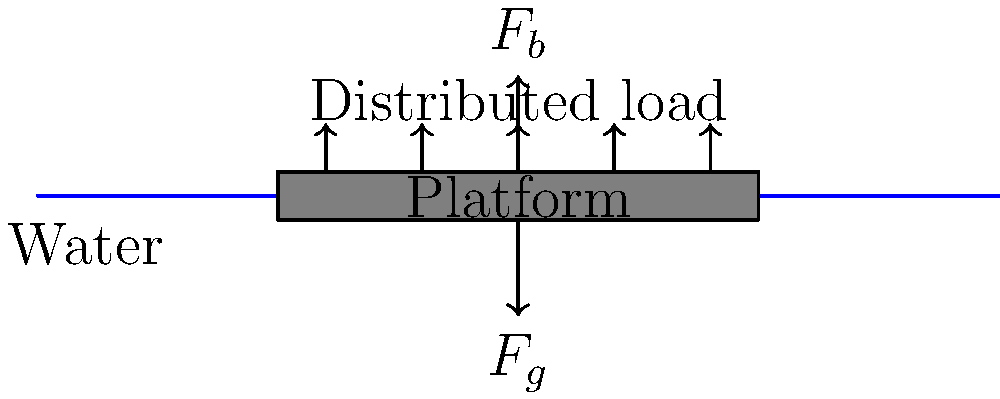A rectangular floating platform for algae cultivation measures 10 m x 5 m and has a uniform thickness of 0.5 m. The platform is made of a material with a density of 300 kg/m³. If the platform is designed to support a uniformly distributed load of algae and equipment weighing 2000 kg, what is the maximum depth to which the platform will sink in freshwater (density 1000 kg/m³)? Assume the platform remains level. To solve this problem, we need to follow these steps:

1. Calculate the volume of the platform:
   $V_{platform} = 10 \text{ m} \times 5 \text{ m} \times 0.5 \text{ m} = 25 \text{ m}^3$

2. Calculate the mass of the platform:
   $m_{platform} = 300 \text{ kg/m}^3 \times 25 \text{ m}^3 = 7500 \text{ kg}$

3. Calculate the total mass (platform + load):
   $m_{total} = 7500 \text{ kg} + 2000 \text{ kg} = 9500 \text{ kg}$

4. Use Archimedes' principle: the buoyant force equals the weight of the displaced water.
   $F_b = F_g$
   $\rho_{water} \times g \times V_{displaced} = m_{total} \times g$

5. Simplify and solve for $V_{displaced}$:
   $V_{displaced} = \frac{m_{total}}{\rho_{water}} = \frac{9500 \text{ kg}}{1000 \text{ kg/m}^3} = 9.5 \text{ m}^3$

6. Calculate the depth (h) the platform will sink:
   $V_{displaced} = \text{Area} \times h$
   $9.5 \text{ m}^3 = (10 \text{ m} \times 5 \text{ m}) \times h$
   $h = \frac{9.5 \text{ m}^3}{50 \text{ m}^2} = 0.19 \text{ m}$

Therefore, the platform will sink to a maximum depth of 0.19 m or 19 cm.
Answer: 0.19 m 